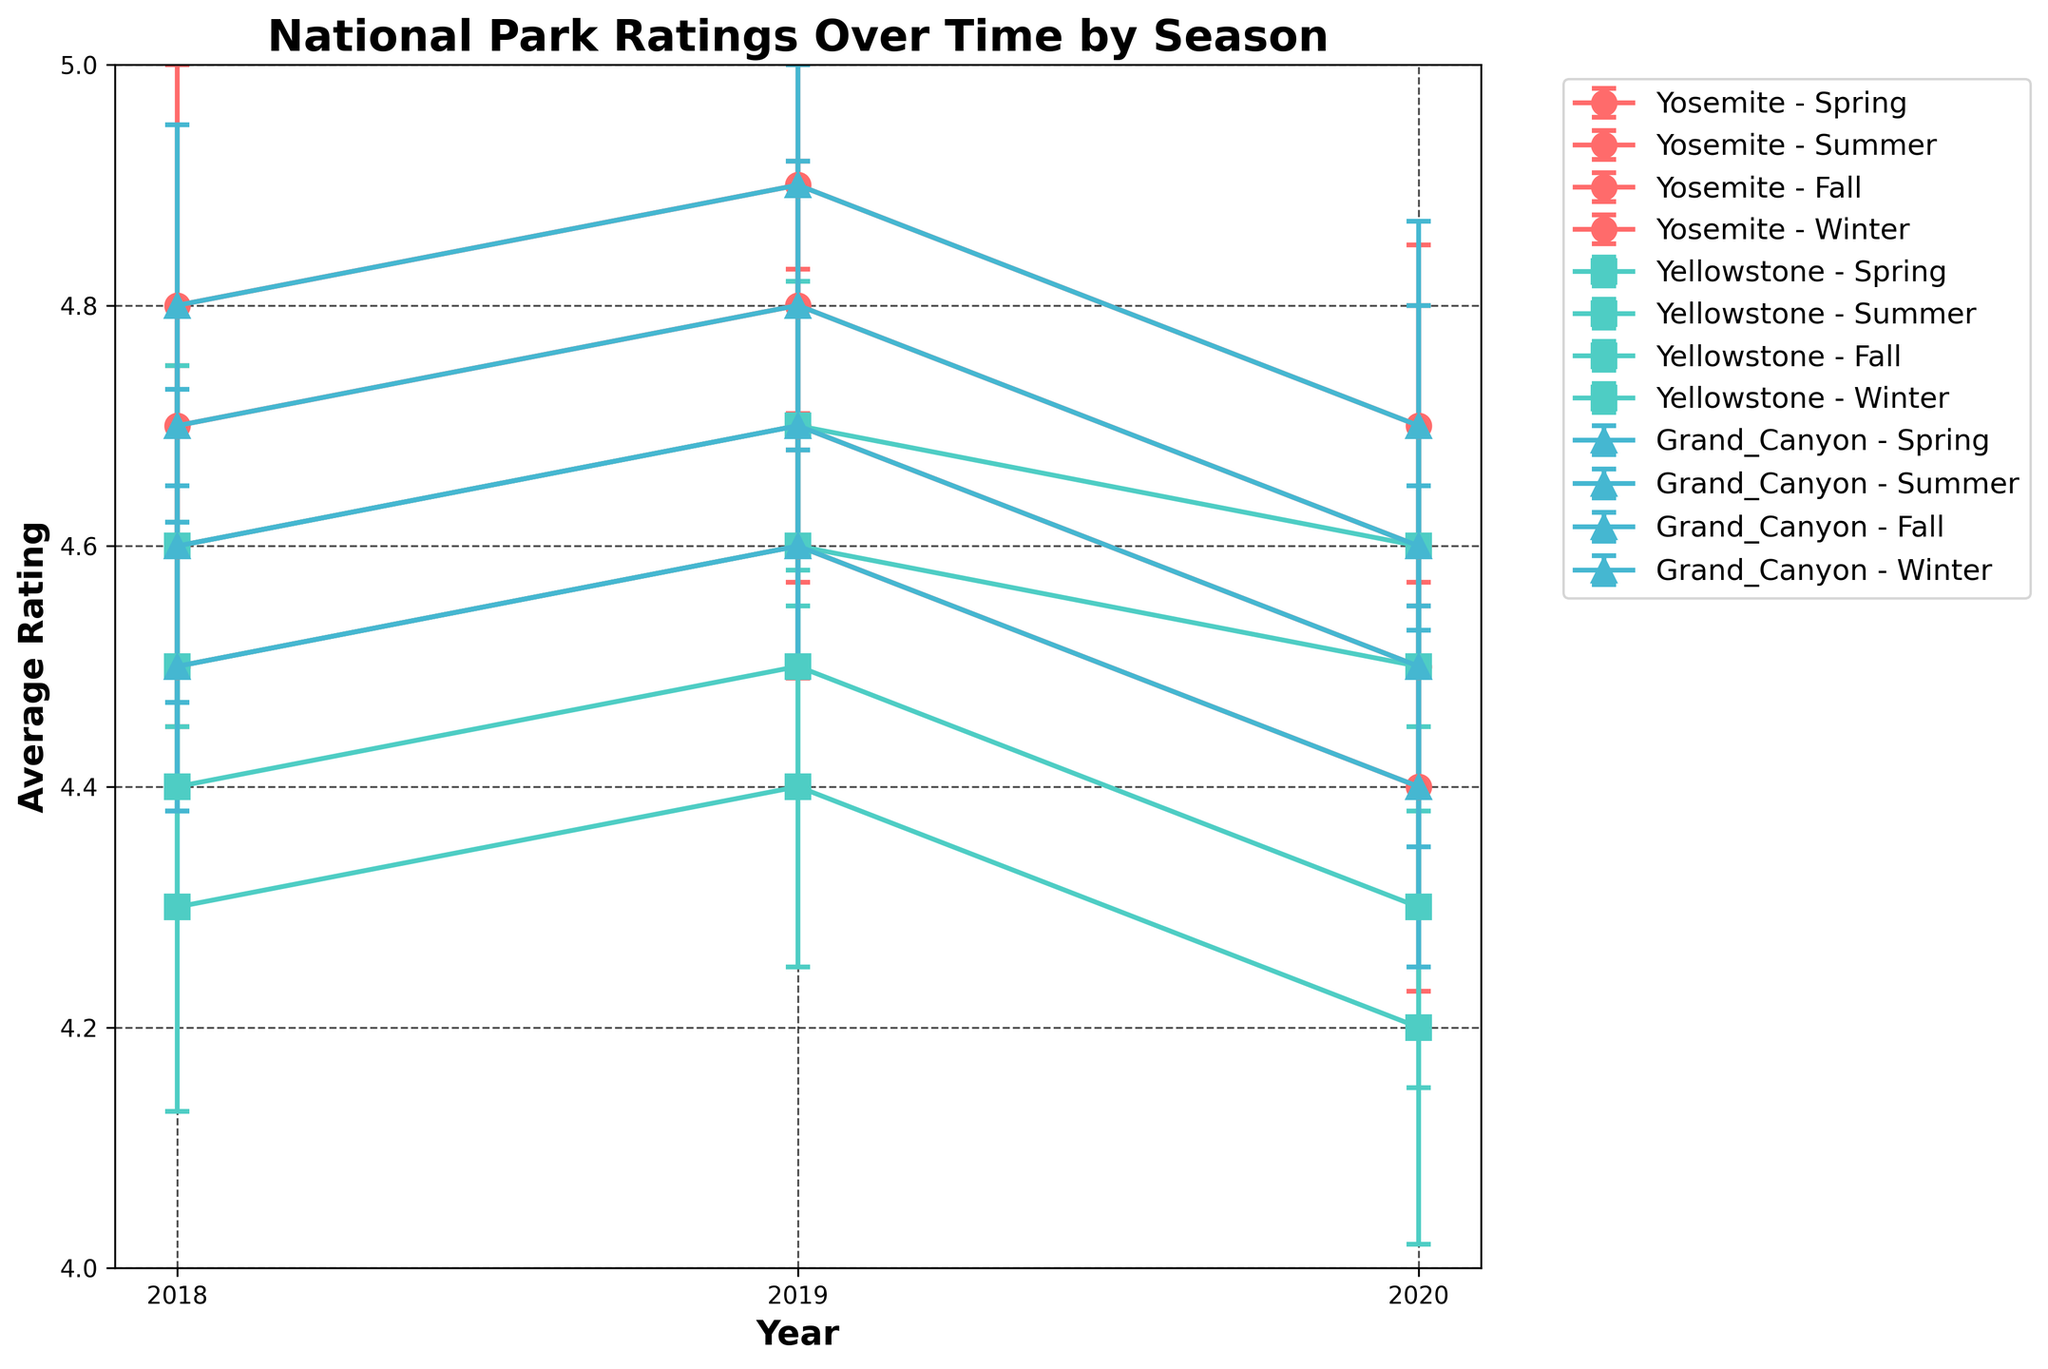What's the title of the plot? The title of the plot is located at the top center and is written in bold.
Answer: National Park Ratings Over Time by Season What are the years displayed on the x-axis? The x-axis has tick marks showing each year in the range of the data.
Answer: 2018, 2019, 2020 What is the label of the y-axis? The label of the y-axis is found along the y-axis, typically written in a readable, bold format.
Answer: Average Rating Which national park has the highest average rating in the Summer of 2019? By examining the line plot for the Summer of 2019 and observing the highest point among the data points, we can find the national park with the highest rating. The marker for this point will be labeled accordingly.
Answer: Grand Canyon How does the average rating of Yosemite in Spring 2020 compare to Spring 2018? Look at the error bars and the central points for Yosemite in Spring 2020 and Spring 2018. Observe the central value (average rating) for both seasons and compare them.
Answer: Lower in 2020 than 2018 Is there a general trend in average ratings for parks from 2018 to 2020? By observing the overall direction of the lines for each park and season, we can identify any upward or downward trends from 2018 to 2020.
Answer: Slightly decreasing In which season does Yellowstone have the largest variability in ratings in 2020? Check the length of the error bars for each season for Yellowstone in 2020 and identify the season with the longest error bars, indicating the largest variability.
Answer: Winter Does Grand Canyon exhibit greater variability in ratings in 2019 or 2020? Compare the lengths of the error bars for Grand Canyon across all seasons in 2019 and 2020. The year with the generally longer error bars indicates greater variability.
Answer: 2020 What is the difference in average rating between Yosemite and Yellowstone in Summer 2019? Locate the average rating points for Yosemite and Yellowstone in Summer 2019 and subtract Yellowstone's rating from Yosemite's rating.
Answer: 0.2 Which season shows the highest average rating for the Grand Canyon over the years? For each year, identify the seasonal average ratings for Grand Canyon and pick the season that consistently has the highest average.
Answer: Summer Compare the average rating of Yosemite in Fall 2018 to the Grand Canyon in Fall 2018. Which is higher? Look at the average rating points for both Yosemite and Grand Canyon in Fall 2018 and compare their heights on the plot.
Answer: Yosemite 